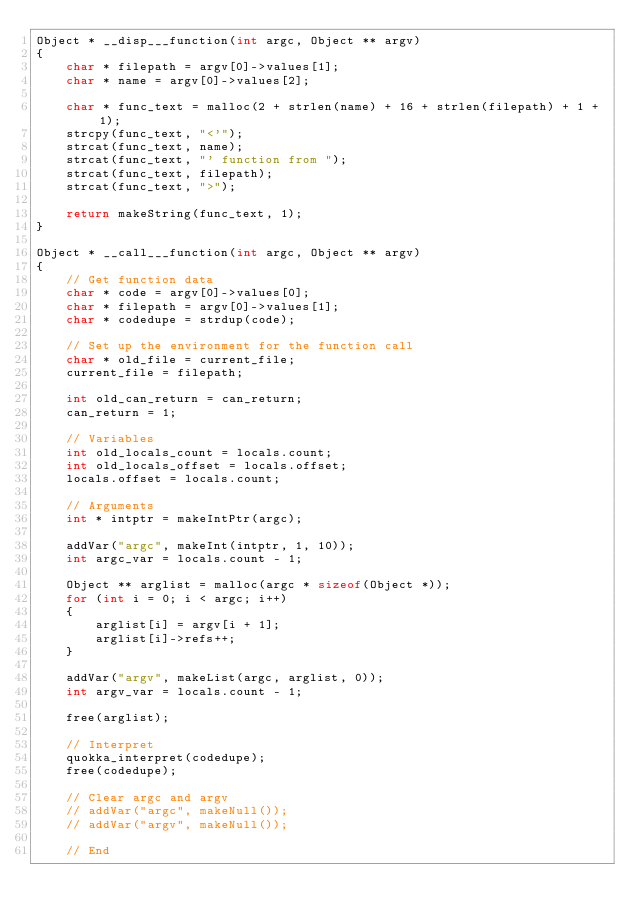<code> <loc_0><loc_0><loc_500><loc_500><_C_>Object * __disp___function(int argc, Object ** argv)
{
    char * filepath = argv[0]->values[1];
    char * name = argv[0]->values[2];

    char * func_text = malloc(2 + strlen(name) + 16 + strlen(filepath) + 1 + 1);
    strcpy(func_text, "<'");
    strcat(func_text, name);
    strcat(func_text, "' function from ");
    strcat(func_text, filepath);
    strcat(func_text, ">");

    return makeString(func_text, 1);
}

Object * __call___function(int argc, Object ** argv)
{
    // Get function data
    char * code = argv[0]->values[0];
    char * filepath = argv[0]->values[1];
    char * codedupe = strdup(code);

    // Set up the environment for the function call
    char * old_file = current_file;
    current_file = filepath;

    int old_can_return = can_return;
    can_return = 1;

    // Variables
    int old_locals_count = locals.count;
    int old_locals_offset = locals.offset;
    locals.offset = locals.count;

    // Arguments
    int * intptr = makeIntPtr(argc);

    addVar("argc", makeInt(intptr, 1, 10));
    int argc_var = locals.count - 1;

    Object ** arglist = malloc(argc * sizeof(Object *));
    for (int i = 0; i < argc; i++)
    {
        arglist[i] = argv[i + 1];
        arglist[i]->refs++;
    }

    addVar("argv", makeList(argc, arglist, 0));
    int argv_var = locals.count - 1;

    free(arglist);

    // Interpret
    quokka_interpret(codedupe);
    free(codedupe);

    // Clear argc and argv
    // addVar("argc", makeNull());
    // addVar("argv", makeNull());

    // End</code> 